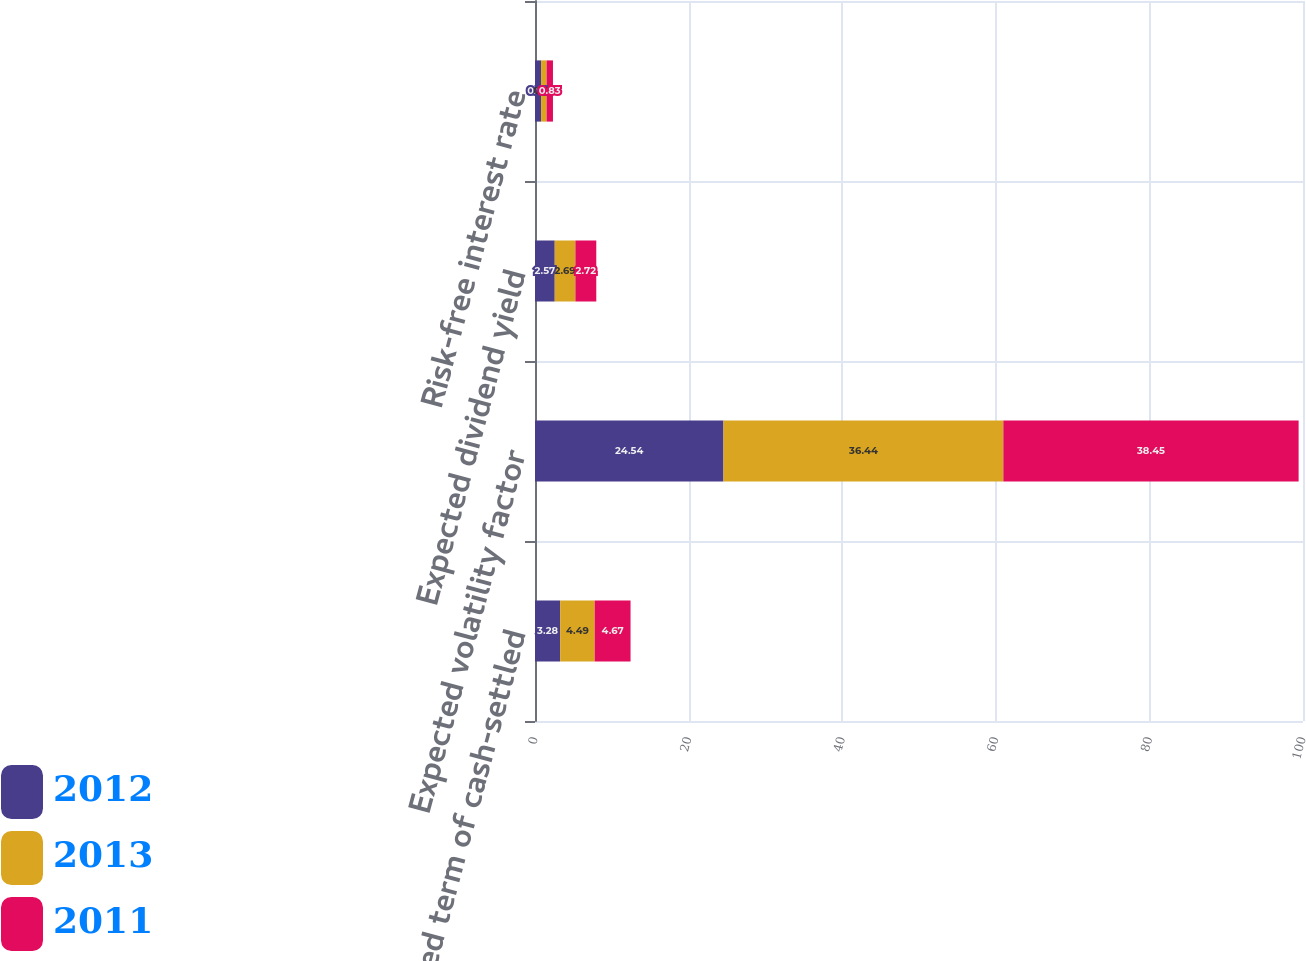<chart> <loc_0><loc_0><loc_500><loc_500><stacked_bar_chart><ecel><fcel>Expected term of cash-settled<fcel>Expected volatility factor<fcel>Expected dividend yield<fcel>Risk-free interest rate<nl><fcel>2012<fcel>3.28<fcel>24.54<fcel>2.57<fcel>0.79<nl><fcel>2013<fcel>4.49<fcel>36.44<fcel>2.69<fcel>0.72<nl><fcel>2011<fcel>4.67<fcel>38.45<fcel>2.72<fcel>0.83<nl></chart> 